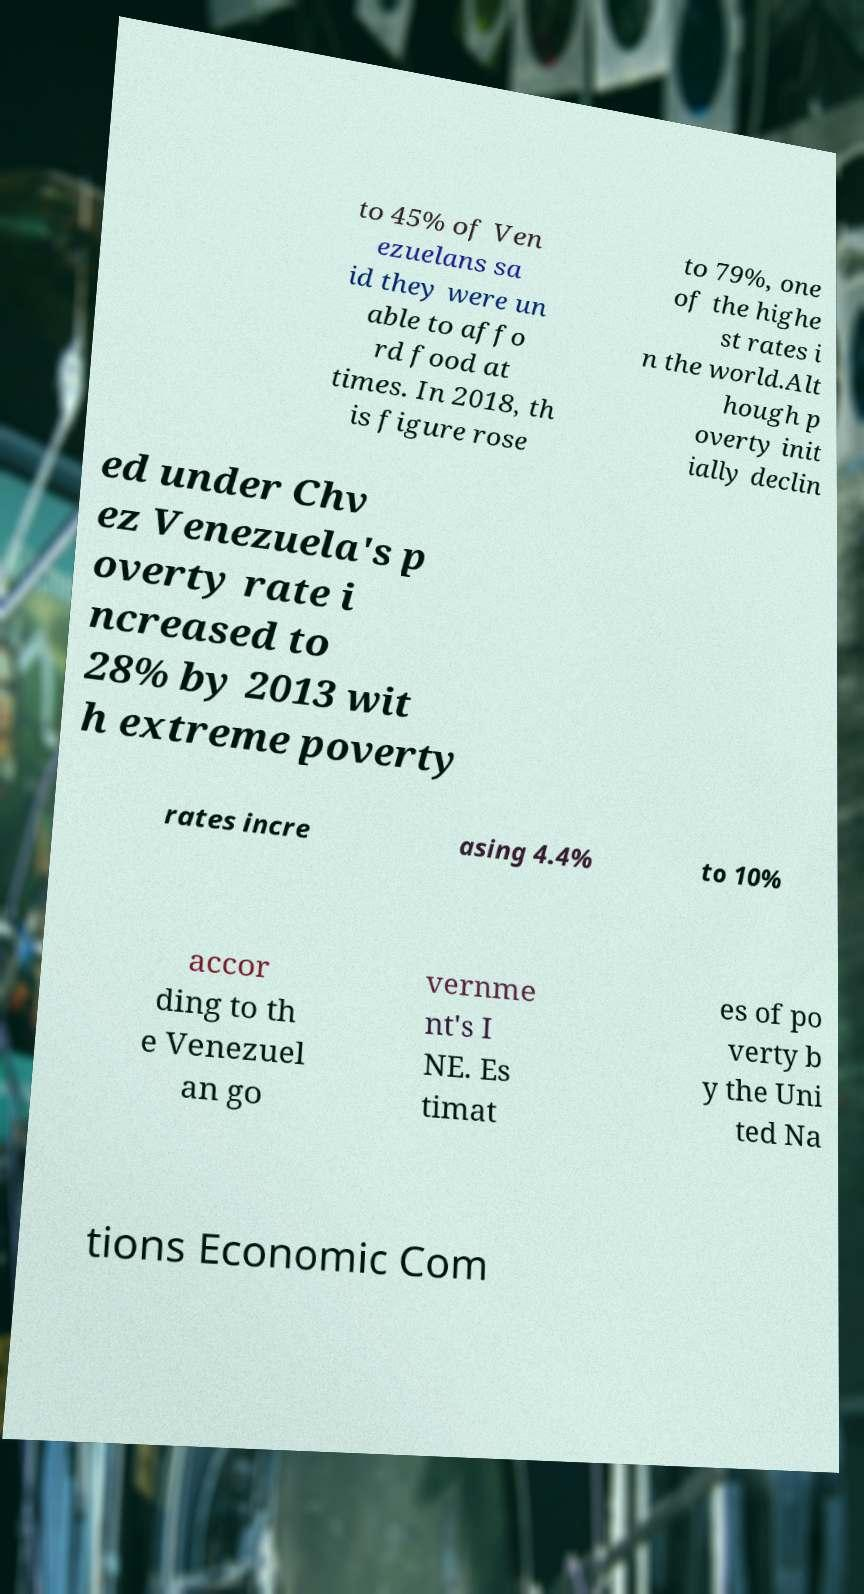Could you extract and type out the text from this image? to 45% of Ven ezuelans sa id they were un able to affo rd food at times. In 2018, th is figure rose to 79%, one of the highe st rates i n the world.Alt hough p overty init ially declin ed under Chv ez Venezuela's p overty rate i ncreased to 28% by 2013 wit h extreme poverty rates incre asing 4.4% to 10% accor ding to th e Venezuel an go vernme nt's I NE. Es timat es of po verty b y the Uni ted Na tions Economic Com 